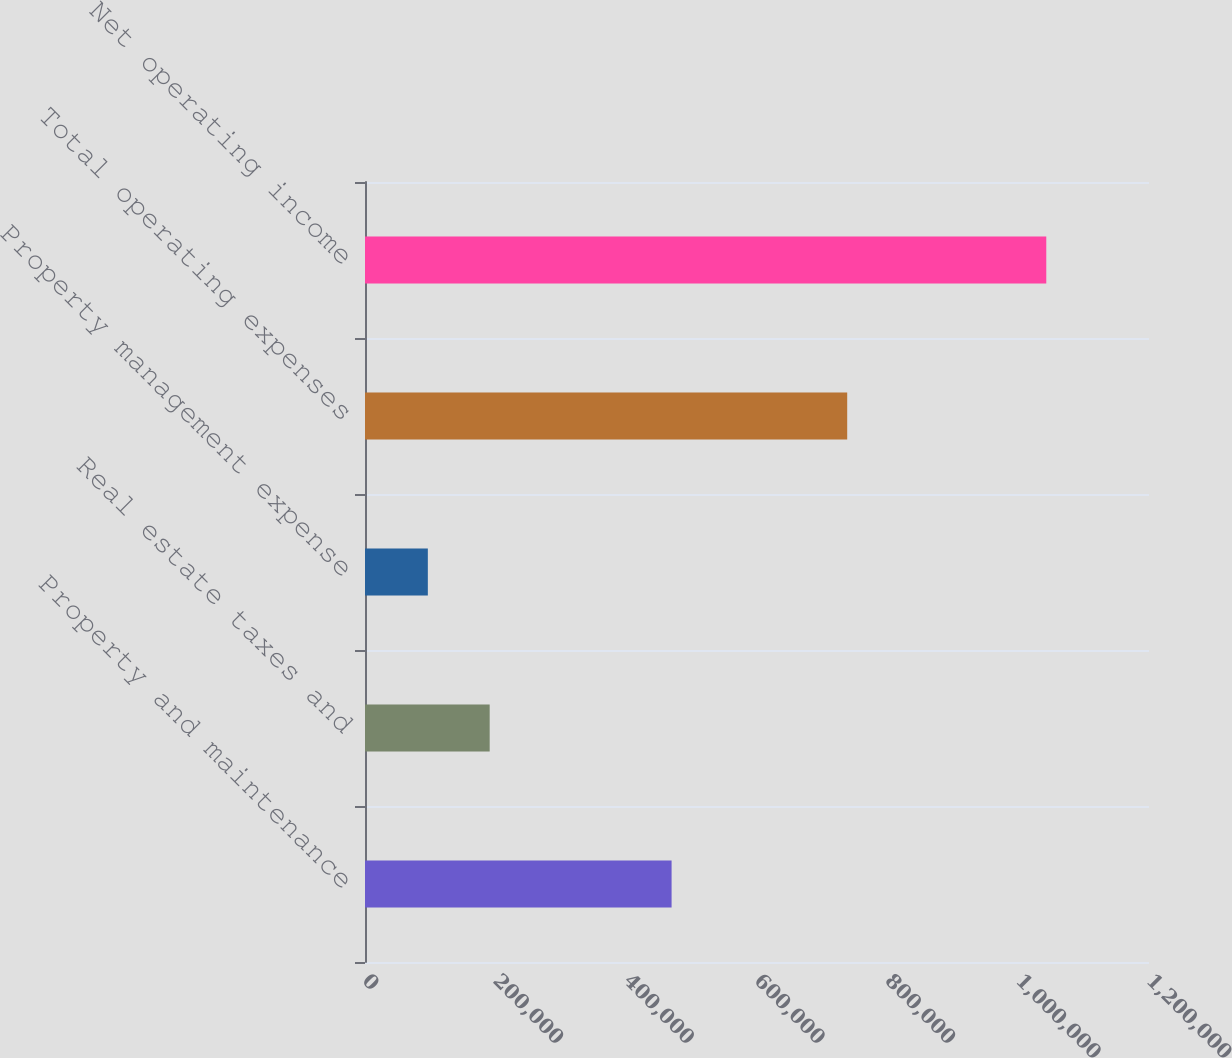Convert chart. <chart><loc_0><loc_0><loc_500><loc_500><bar_chart><fcel>Property and maintenance<fcel>Real estate taxes and<fcel>Property management expense<fcel>Total operating expenses<fcel>Net operating income<nl><fcel>469267<fcel>190837<fcel>96178<fcel>738063<fcel>1.04277e+06<nl></chart> 